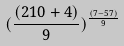<formula> <loc_0><loc_0><loc_500><loc_500>( \frac { ( 2 1 0 + 4 ) } { 9 } ) ^ { \frac { ( 7 - 5 7 ) } { 9 } }</formula> 